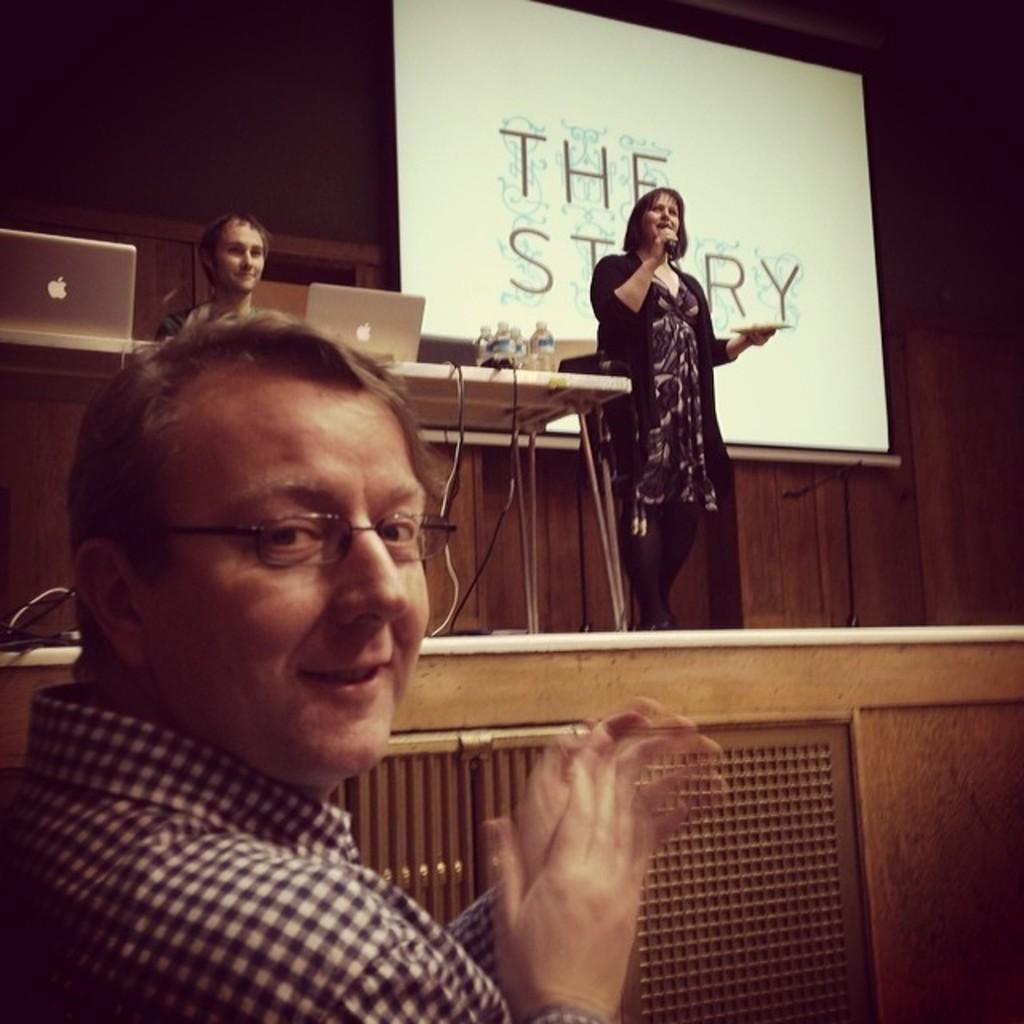How would you summarize this image in a sentence or two? There is one man at the bottom of this image, and there is one woman standing on the stage and holding a Mic in the middle of this image , and there is one person sitting on the left side of this image. There are two laptops and some bottles are kept on a table in the middle of this image, and there a wooden wall in the background. We can see there is a screen at the top of this image. 